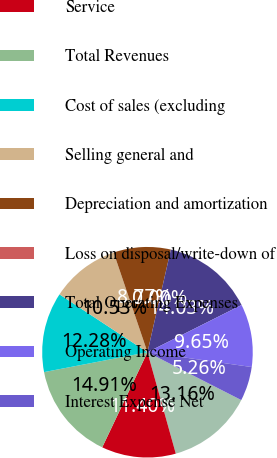Convert chart to OTSL. <chart><loc_0><loc_0><loc_500><loc_500><pie_chart><fcel>Storage rental<fcel>Service<fcel>Total Revenues<fcel>Cost of sales (excluding<fcel>Selling general and<fcel>Depreciation and amortization<fcel>Loss on disposal/write-down of<fcel>Total Operating Expenses<fcel>Operating Income<fcel>Interest Expense Net<nl><fcel>13.16%<fcel>11.4%<fcel>14.91%<fcel>12.28%<fcel>10.53%<fcel>8.77%<fcel>0.0%<fcel>14.03%<fcel>9.65%<fcel>5.26%<nl></chart> 